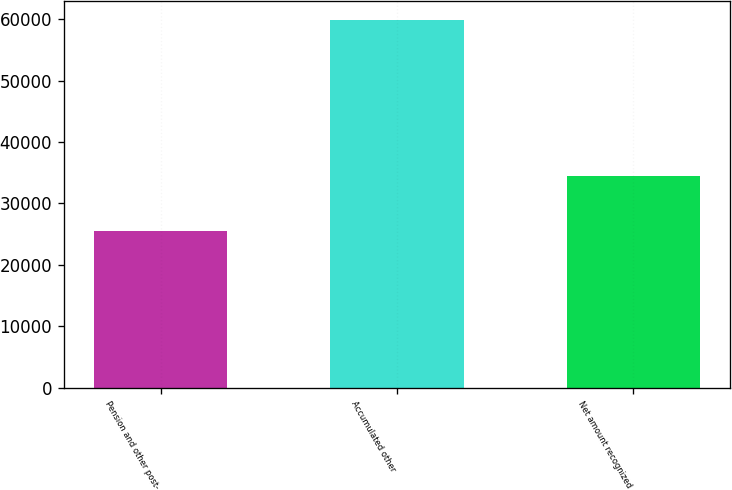Convert chart to OTSL. <chart><loc_0><loc_0><loc_500><loc_500><bar_chart><fcel>Pension and other post-<fcel>Accumulated other<fcel>Net amount recognized<nl><fcel>25441<fcel>59874<fcel>34433<nl></chart> 